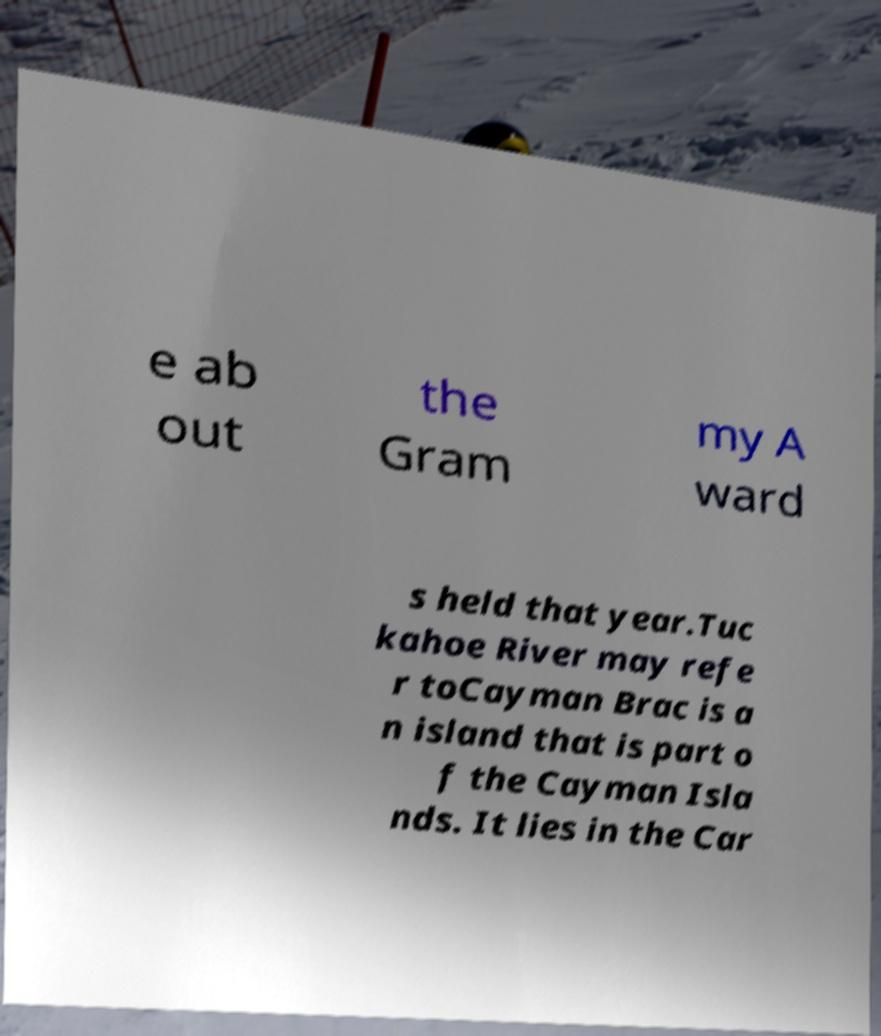I need the written content from this picture converted into text. Can you do that? e ab out the Gram my A ward s held that year.Tuc kahoe River may refe r toCayman Brac is a n island that is part o f the Cayman Isla nds. It lies in the Car 